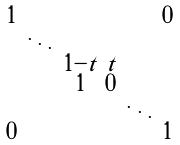Convert formula to latex. <formula><loc_0><loc_0><loc_500><loc_500>\begin{smallmatrix} 1 & & & & & 0 \\ & \ddots & & & & \\ & & 1 - t & t & & \\ & & 1 & 0 & & & \\ & & & & \ddots & \\ 0 & & & & & 1 \\ \end{smallmatrix}</formula> 